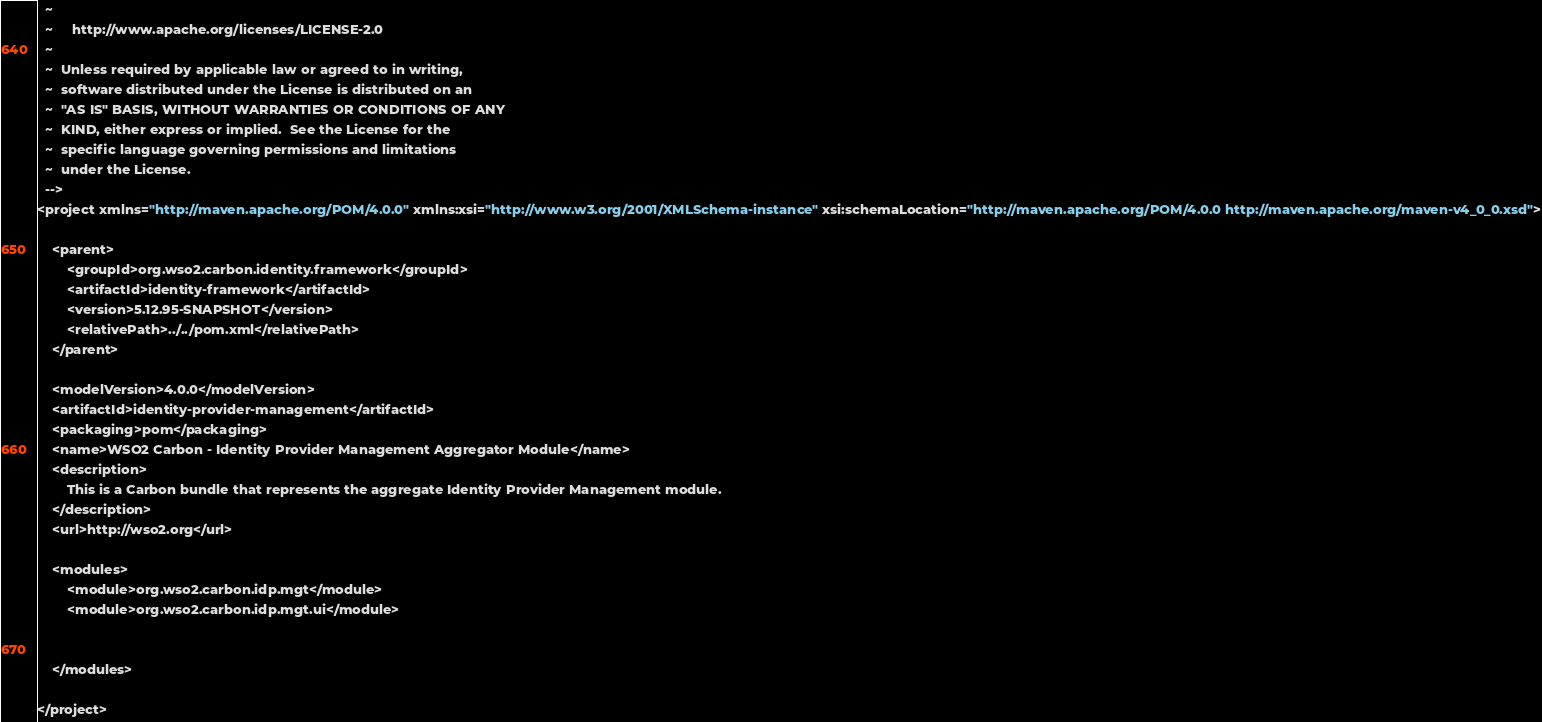<code> <loc_0><loc_0><loc_500><loc_500><_XML_>  ~
  ~     http://www.apache.org/licenses/LICENSE-2.0
  ~
  ~  Unless required by applicable law or agreed to in writing,
  ~  software distributed under the License is distributed on an
  ~  "AS IS" BASIS, WITHOUT WARRANTIES OR CONDITIONS OF ANY
  ~  KIND, either express or implied.  See the License for the
  ~  specific language governing permissions and limitations
  ~  under the License.
  -->
<project xmlns="http://maven.apache.org/POM/4.0.0" xmlns:xsi="http://www.w3.org/2001/XMLSchema-instance" xsi:schemaLocation="http://maven.apache.org/POM/4.0.0 http://maven.apache.org/maven-v4_0_0.xsd">

    <parent>
        <groupId>org.wso2.carbon.identity.framework</groupId>
        <artifactId>identity-framework</artifactId>
        <version>5.12.95-SNAPSHOT</version>
        <relativePath>../../pom.xml</relativePath>
    </parent>

    <modelVersion>4.0.0</modelVersion>
    <artifactId>identity-provider-management</artifactId>
    <packaging>pom</packaging>
    <name>WSO2 Carbon - Identity Provider Management Aggregator Module</name>
    <description>
        This is a Carbon bundle that represents the aggregate Identity Provider Management module.
    </description>
    <url>http://wso2.org</url>

    <modules>
        <module>org.wso2.carbon.idp.mgt</module>
        <module>org.wso2.carbon.idp.mgt.ui</module>


    </modules>

</project>
</code> 